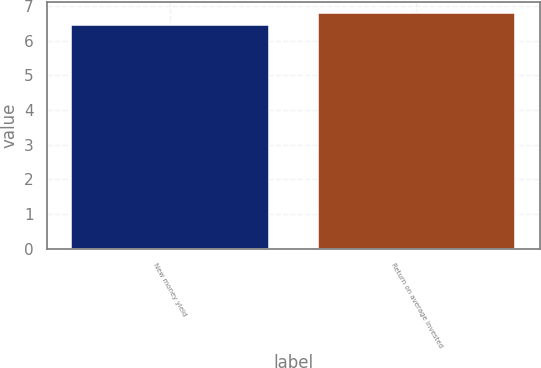<chart> <loc_0><loc_0><loc_500><loc_500><bar_chart><fcel>New money yield<fcel>Return on average invested<nl><fcel>6.44<fcel>6.79<nl></chart> 